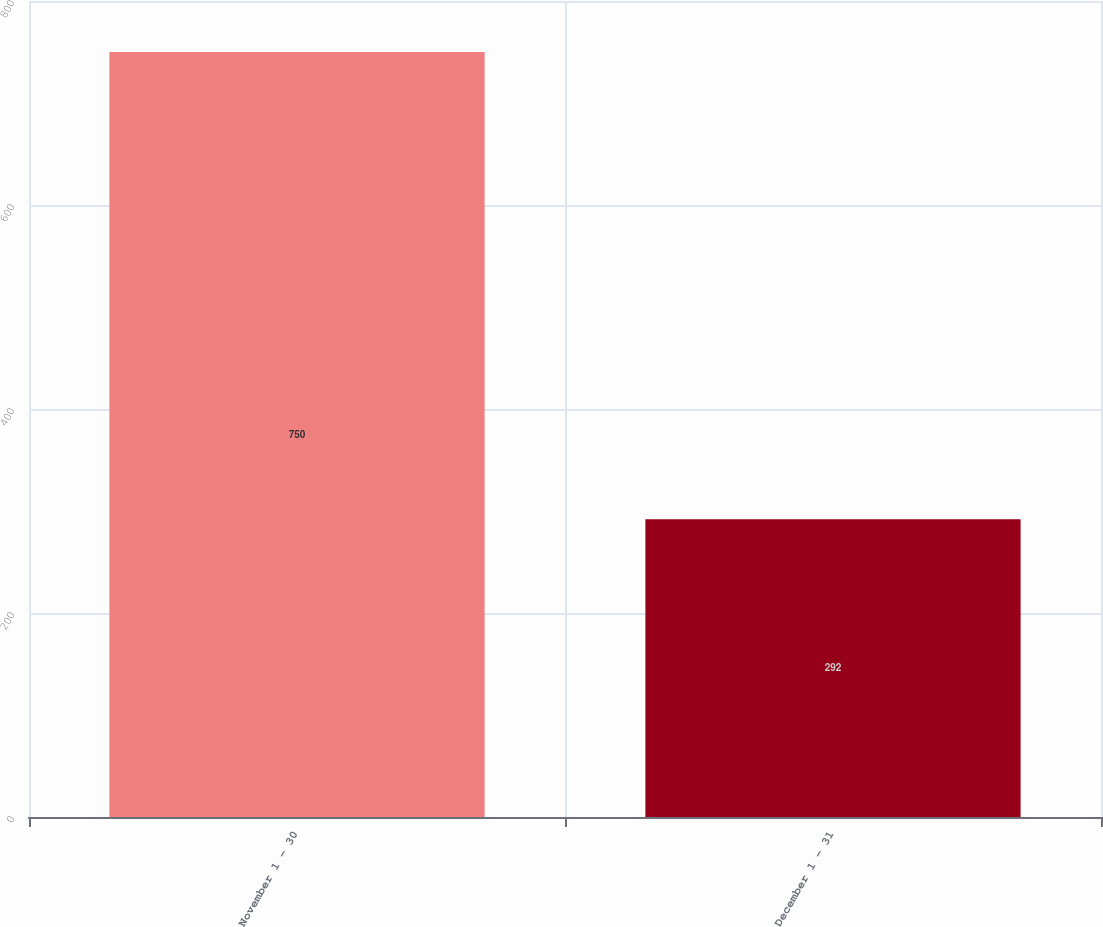Convert chart to OTSL. <chart><loc_0><loc_0><loc_500><loc_500><bar_chart><fcel>November 1 - 30<fcel>December 1 - 31<nl><fcel>750<fcel>292<nl></chart> 